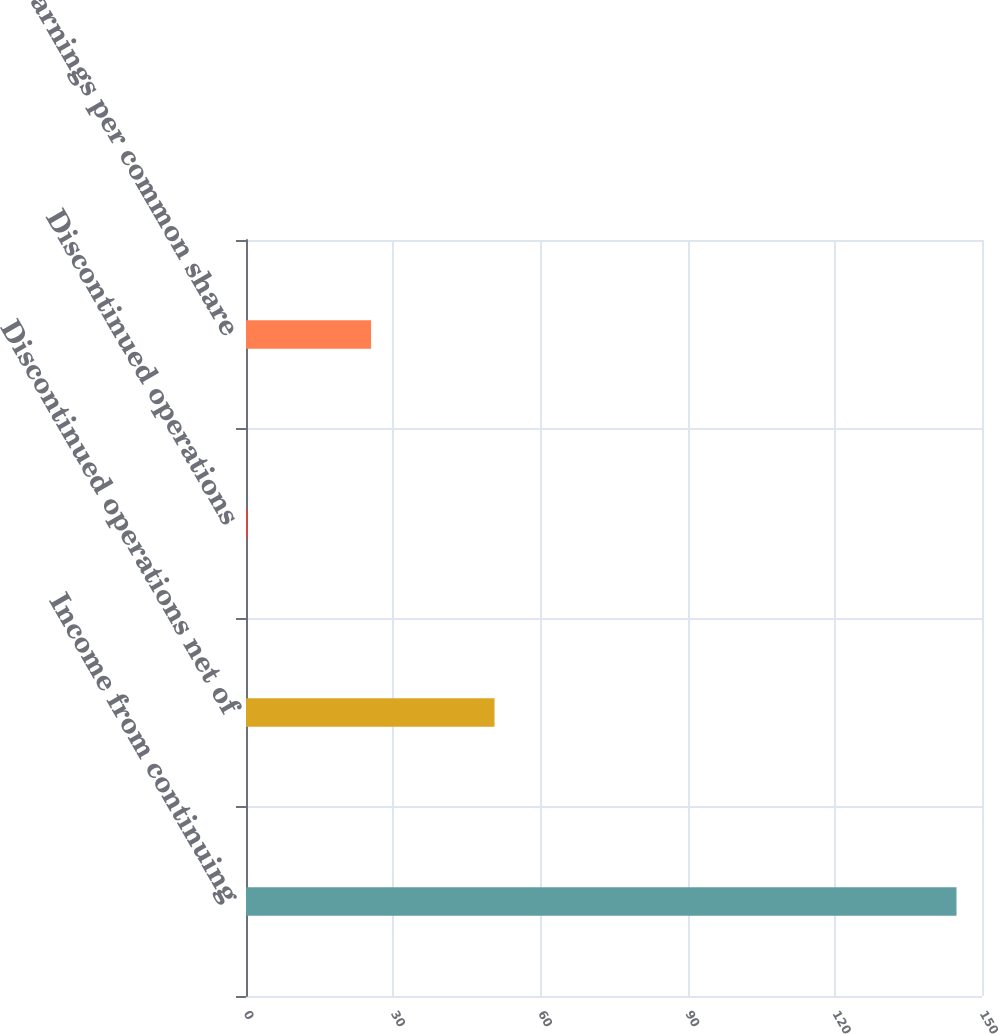<chart> <loc_0><loc_0><loc_500><loc_500><bar_chart><fcel>Income from continuing<fcel>Discontinued operations net of<fcel>Discontinued operations<fcel>Net earnings per common share<nl><fcel>144.8<fcel>50.65<fcel>0.33<fcel>25.49<nl></chart> 